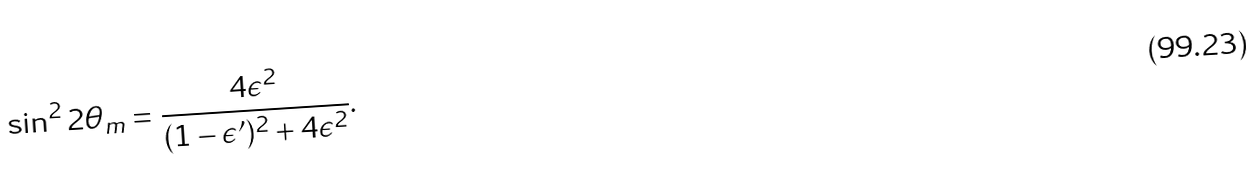<formula> <loc_0><loc_0><loc_500><loc_500>\sin ^ { 2 } 2 \theta _ { m } = \frac { 4 \epsilon ^ { 2 } } { ( 1 - \epsilon ^ { \prime } ) ^ { 2 } + 4 \epsilon ^ { 2 } } .</formula> 